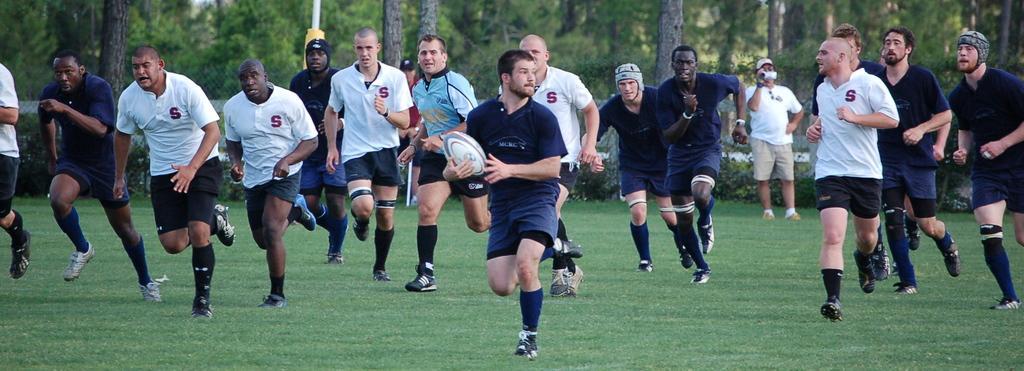Please provide a concise description of this image. In the image we can see there are people who are running on the ground and the ground is covered with grass and a person is holding a rugby ball in his hand. 